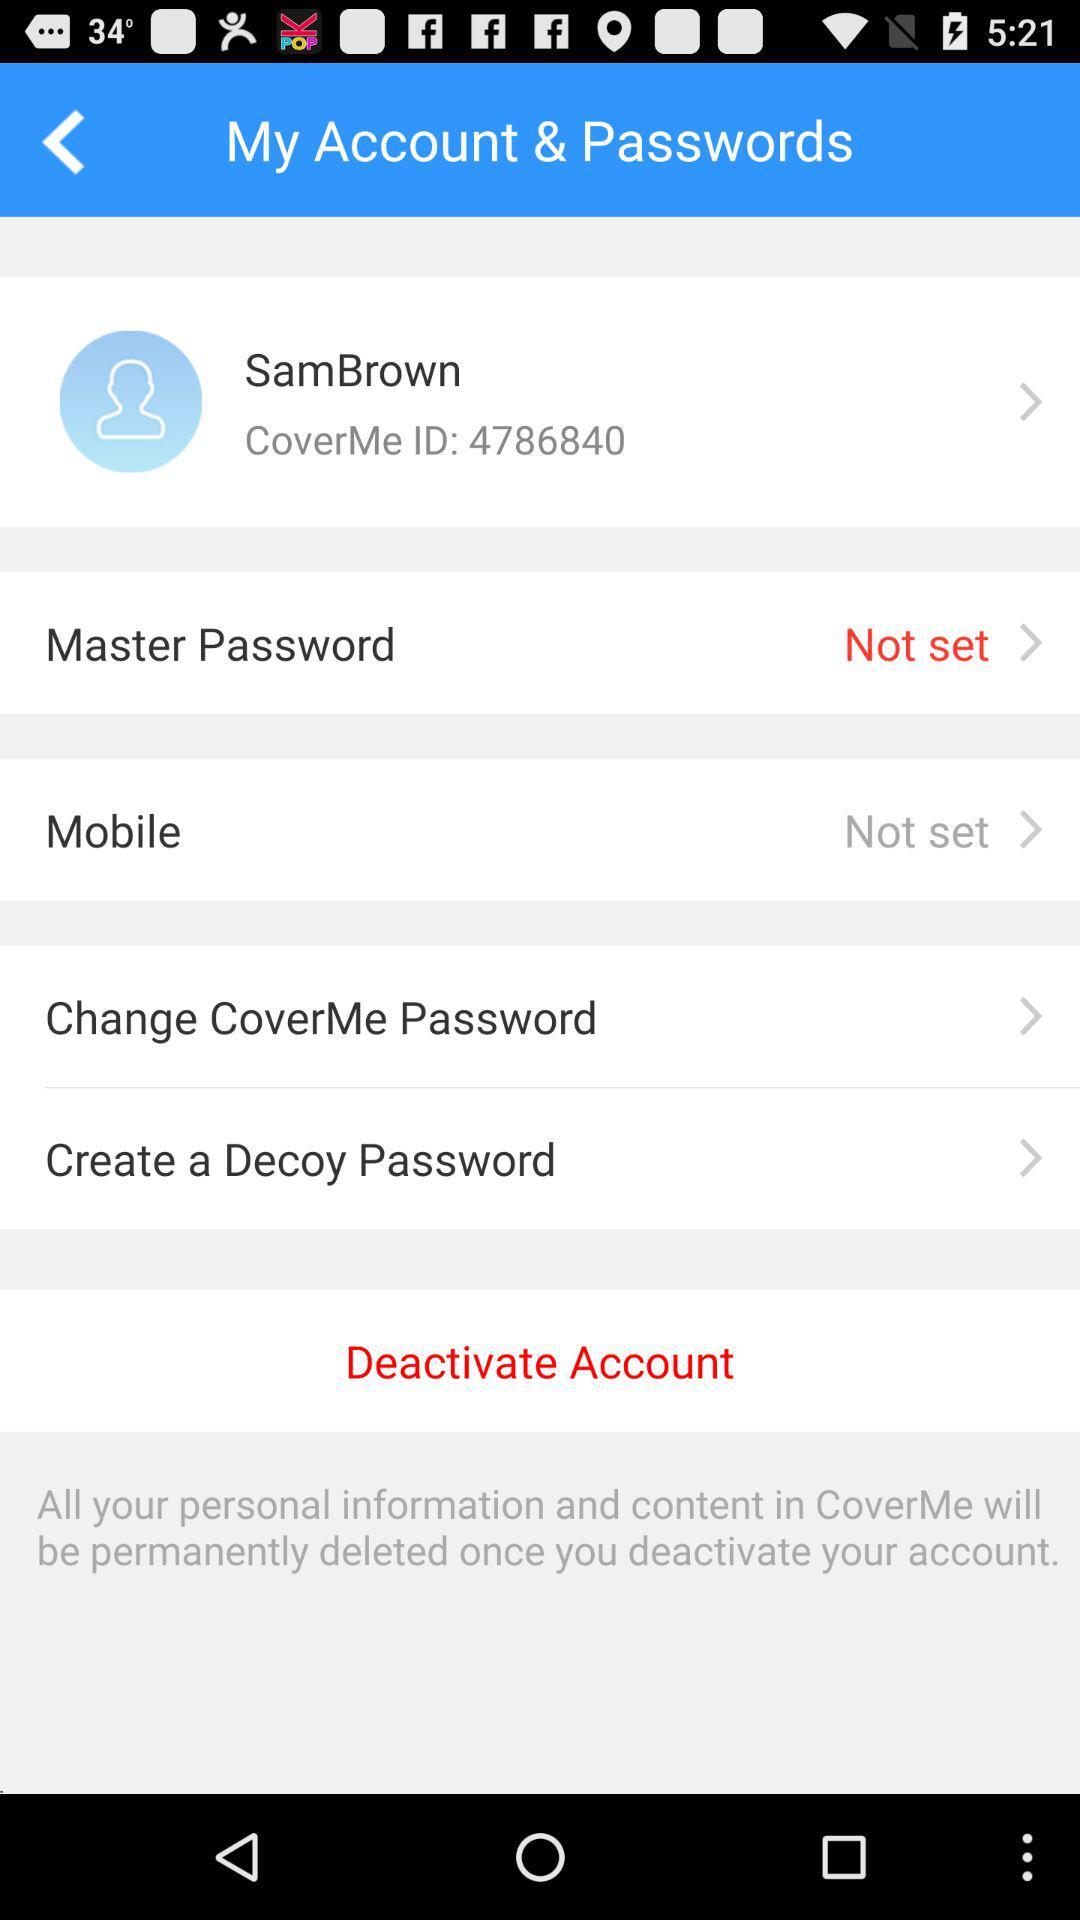What is the username? The username is "SamBrown". 